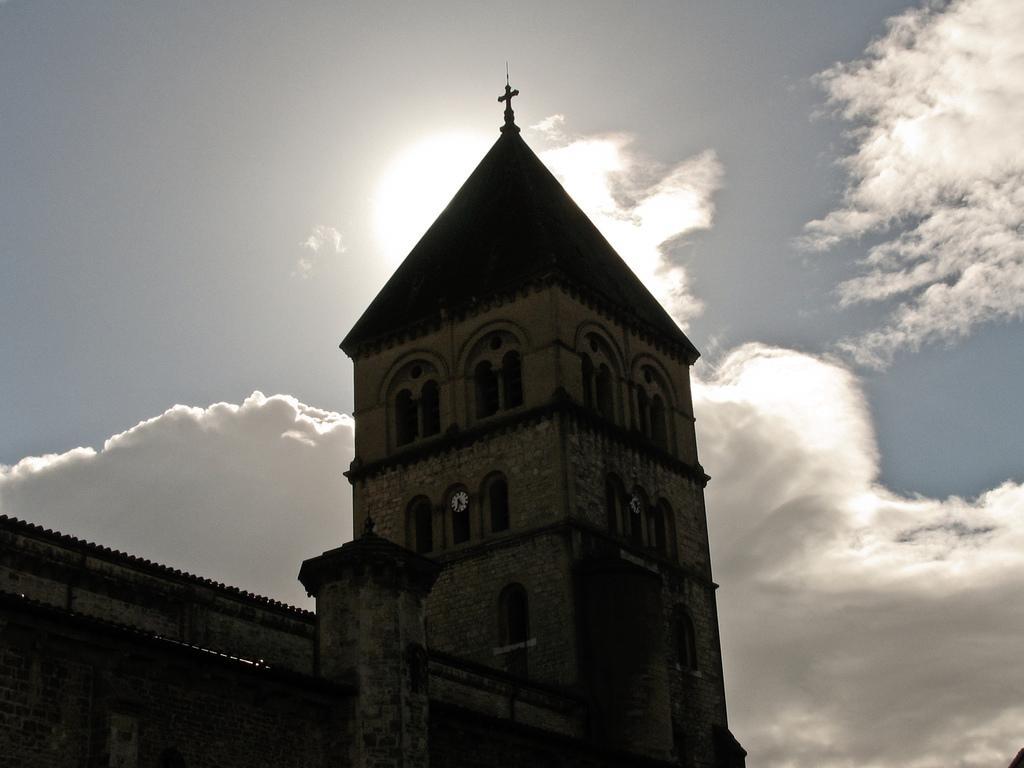In one or two sentences, can you explain what this image depicts? In this image we can see one church, two clocks, one cross at the top of the church, one object in the bottom right side corner of the image and in the background there is the sun in the cloudy sky. 